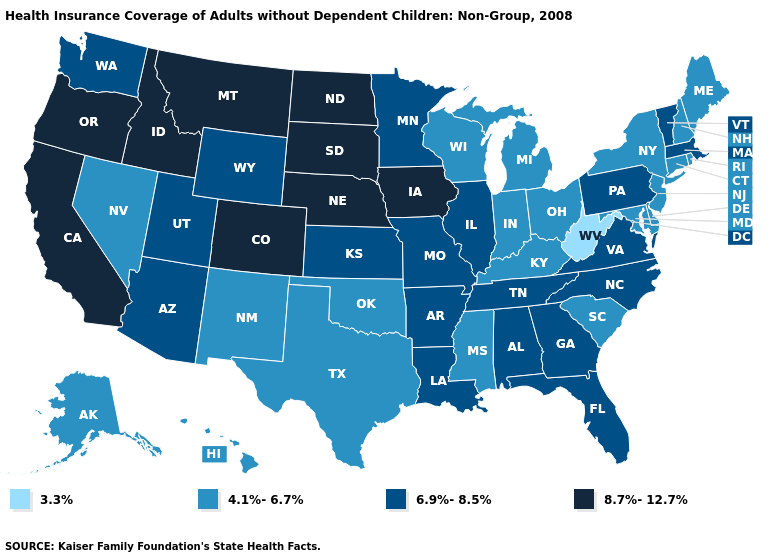Name the states that have a value in the range 4.1%-6.7%?
Give a very brief answer. Alaska, Connecticut, Delaware, Hawaii, Indiana, Kentucky, Maine, Maryland, Michigan, Mississippi, Nevada, New Hampshire, New Jersey, New Mexico, New York, Ohio, Oklahoma, Rhode Island, South Carolina, Texas, Wisconsin. What is the value of West Virginia?
Keep it brief. 3.3%. What is the lowest value in states that border Connecticut?
Answer briefly. 4.1%-6.7%. Does Vermont have the same value as Nebraska?
Keep it brief. No. Does Washington have the same value as Florida?
Be succinct. Yes. What is the value of Pennsylvania?
Give a very brief answer. 6.9%-8.5%. Among the states that border Illinois , which have the highest value?
Keep it brief. Iowa. Name the states that have a value in the range 4.1%-6.7%?
Be succinct. Alaska, Connecticut, Delaware, Hawaii, Indiana, Kentucky, Maine, Maryland, Michigan, Mississippi, Nevada, New Hampshire, New Jersey, New Mexico, New York, Ohio, Oklahoma, Rhode Island, South Carolina, Texas, Wisconsin. What is the value of Arizona?
Concise answer only. 6.9%-8.5%. What is the value of West Virginia?
Answer briefly. 3.3%. Among the states that border Ohio , which have the highest value?
Be succinct. Pennsylvania. Name the states that have a value in the range 4.1%-6.7%?
Answer briefly. Alaska, Connecticut, Delaware, Hawaii, Indiana, Kentucky, Maine, Maryland, Michigan, Mississippi, Nevada, New Hampshire, New Jersey, New Mexico, New York, Ohio, Oklahoma, Rhode Island, South Carolina, Texas, Wisconsin. What is the lowest value in the West?
Quick response, please. 4.1%-6.7%. Which states have the lowest value in the USA?
Short answer required. West Virginia. 